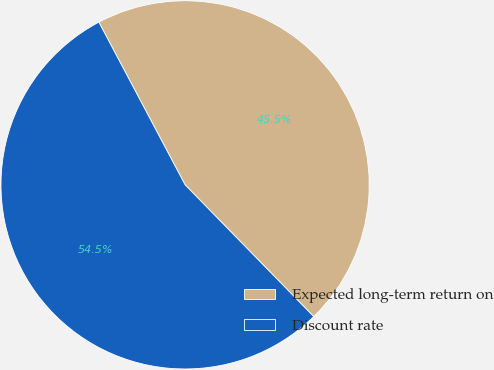<chart> <loc_0><loc_0><loc_500><loc_500><pie_chart><fcel>Expected long-term return on<fcel>Discount rate<nl><fcel>45.45%<fcel>54.55%<nl></chart> 